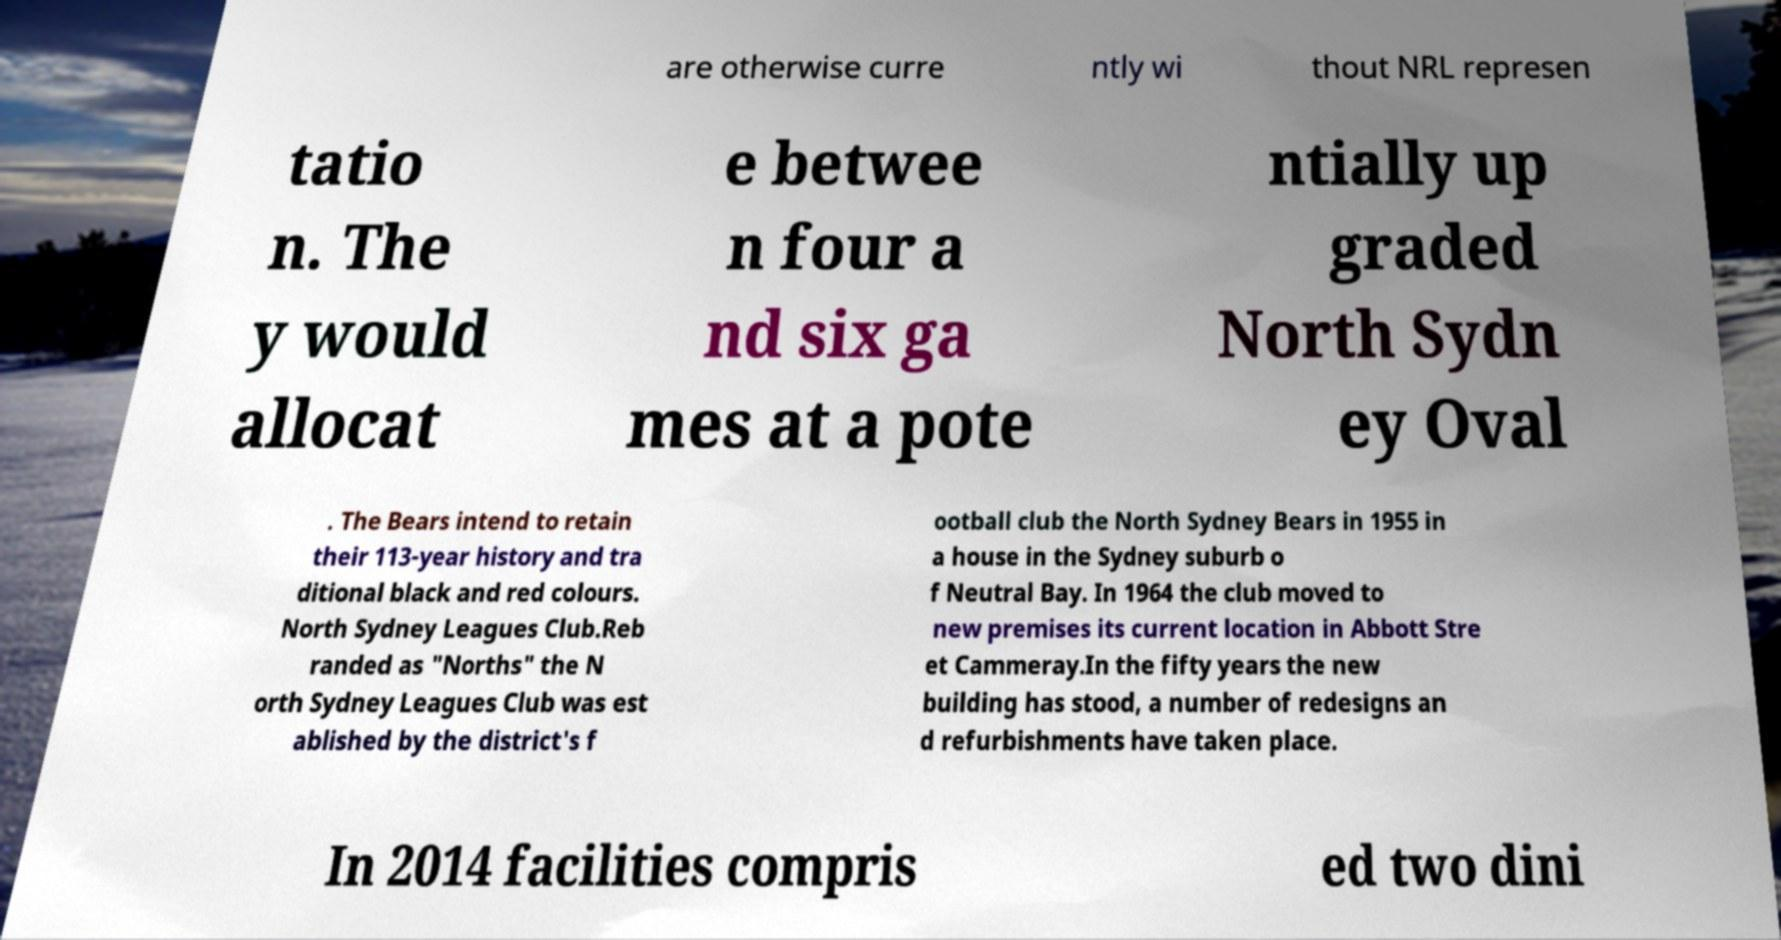What messages or text are displayed in this image? I need them in a readable, typed format. are otherwise curre ntly wi thout NRL represen tatio n. The y would allocat e betwee n four a nd six ga mes at a pote ntially up graded North Sydn ey Oval . The Bears intend to retain their 113-year history and tra ditional black and red colours. North Sydney Leagues Club.Reb randed as "Norths" the N orth Sydney Leagues Club was est ablished by the district's f ootball club the North Sydney Bears in 1955 in a house in the Sydney suburb o f Neutral Bay. In 1964 the club moved to new premises its current location in Abbott Stre et Cammeray.In the fifty years the new building has stood, a number of redesigns an d refurbishments have taken place. In 2014 facilities compris ed two dini 